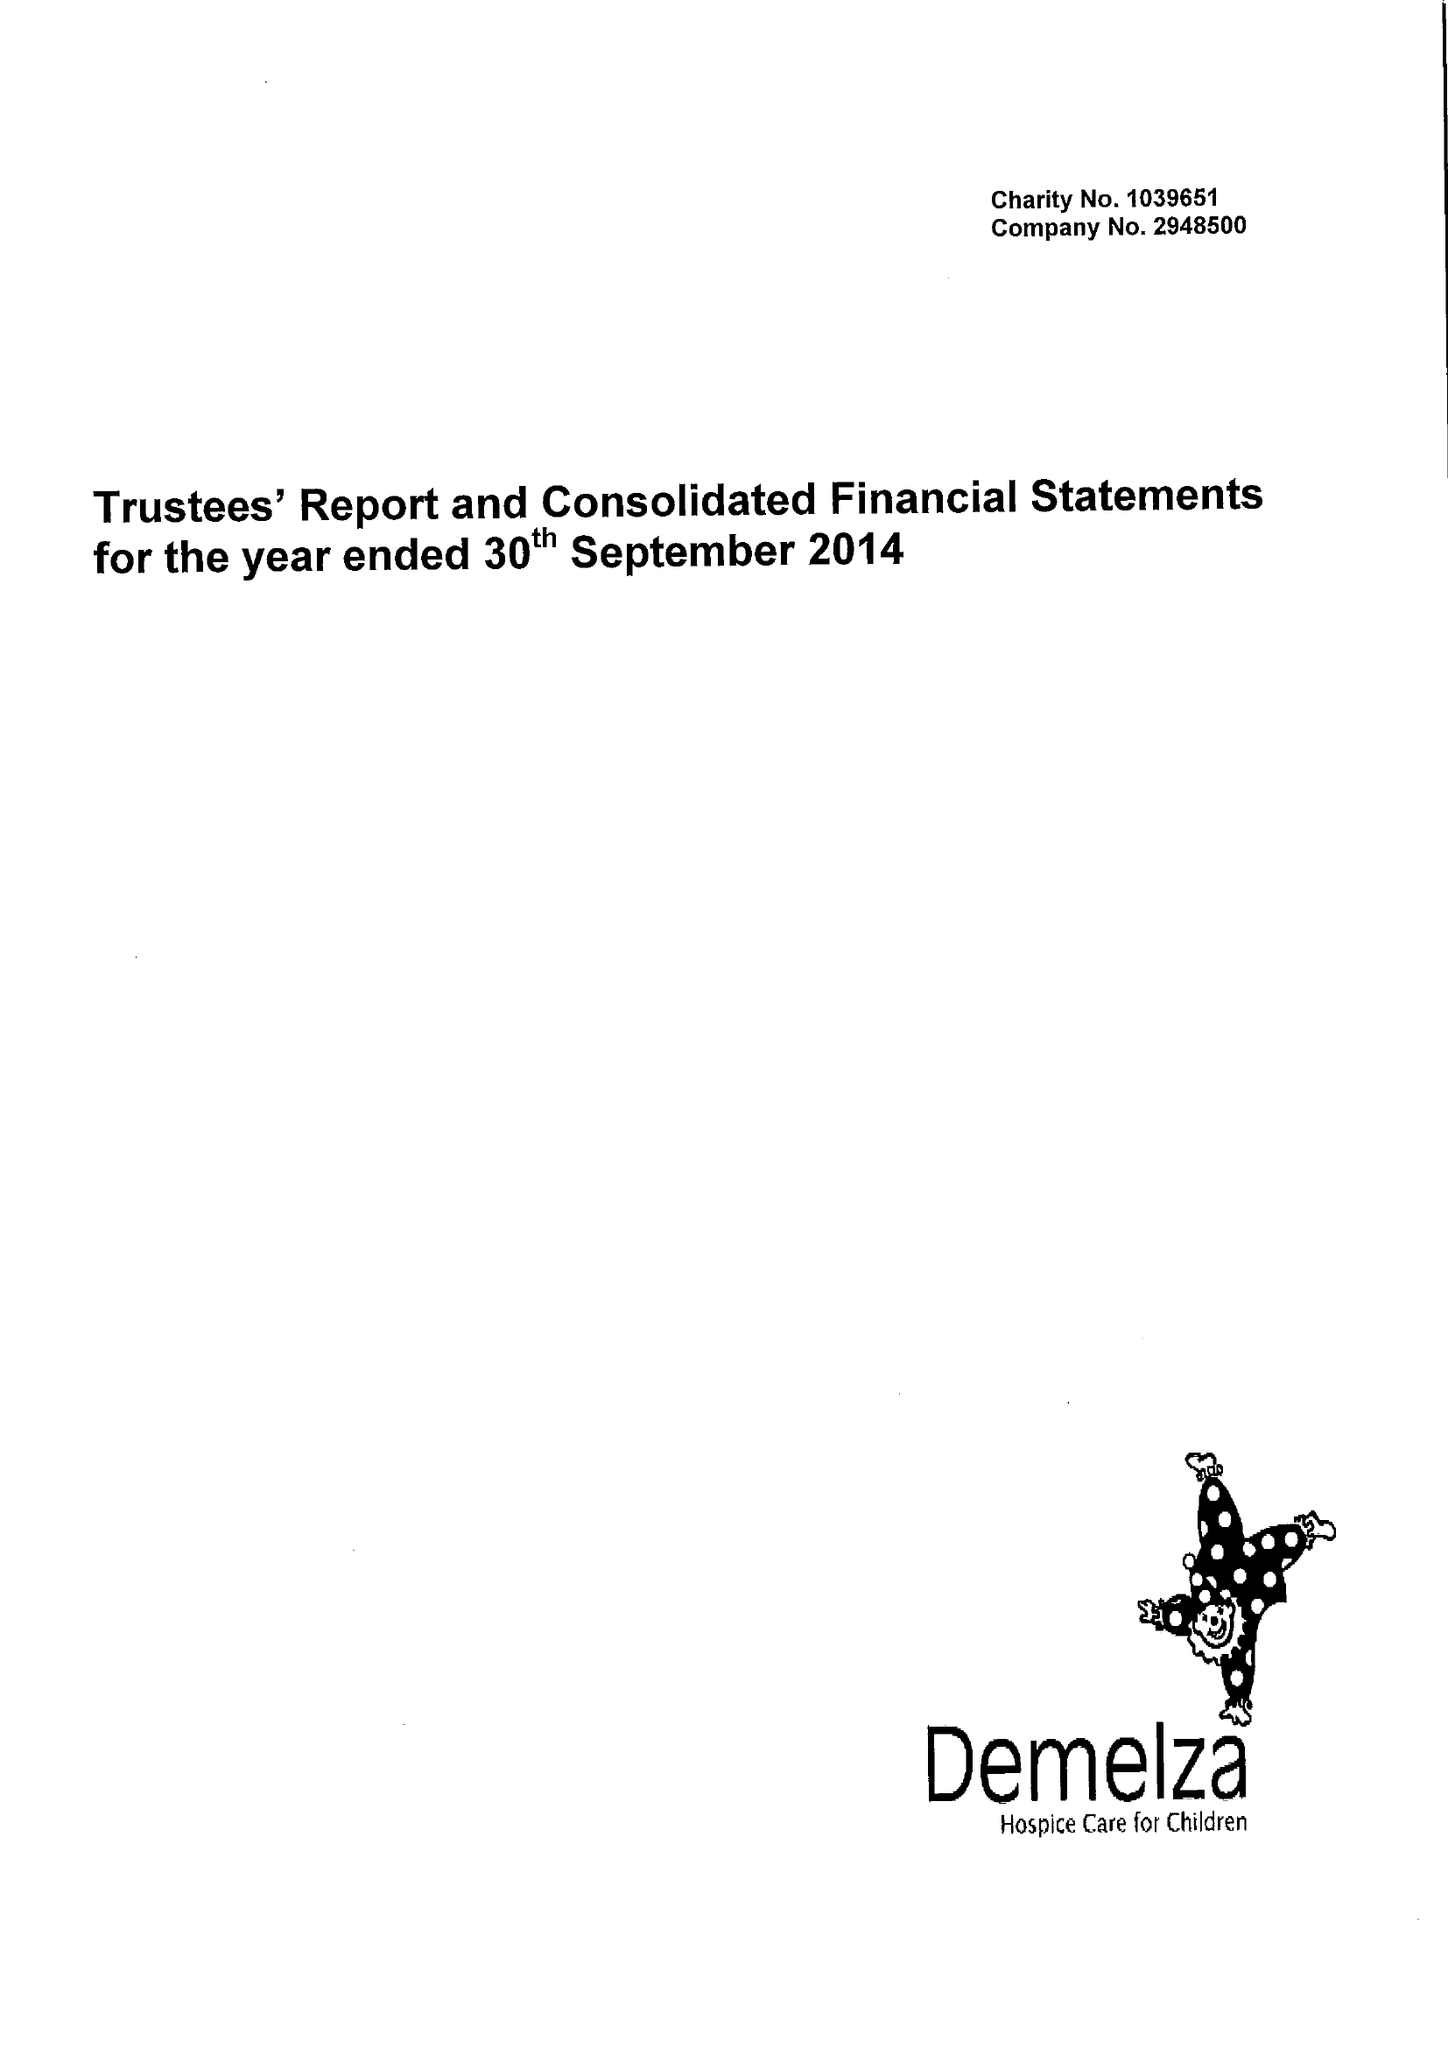What is the value for the spending_annually_in_british_pounds?
Answer the question using a single word or phrase. 9983878.00 